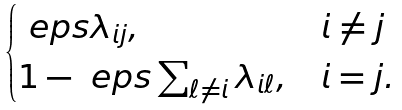<formula> <loc_0><loc_0><loc_500><loc_500>\begin{cases} \ e p s \lambda _ { i j } , & i \ne j \\ 1 - \ e p s \sum _ { \ell \ne i } \lambda _ { i \ell } , & i = j . \end{cases}</formula> 